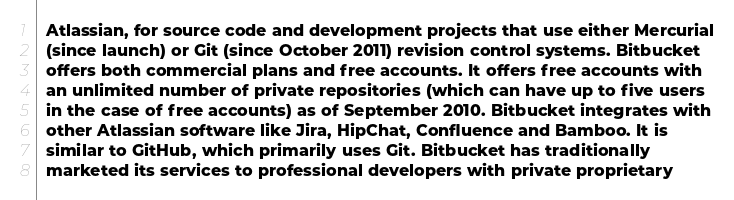<code> <loc_0><loc_0><loc_500><loc_500><_YAML_>  Atlassian, for source code and development projects that use either Mercurial
  (since launch) or Git (since October 2011) revision control systems. Bitbucket
  offers both commercial plans and free accounts. It offers free accounts with
  an unlimited number of private repositories (which can have up to five users
  in the case of free accounts) as of September 2010. Bitbucket integrates with
  other Atlassian software like Jira, HipChat, Confluence and Bamboo. It is
  similar to GitHub, which primarily uses Git. Bitbucket has traditionally
  marketed its services to professional developers with private proprietary</code> 